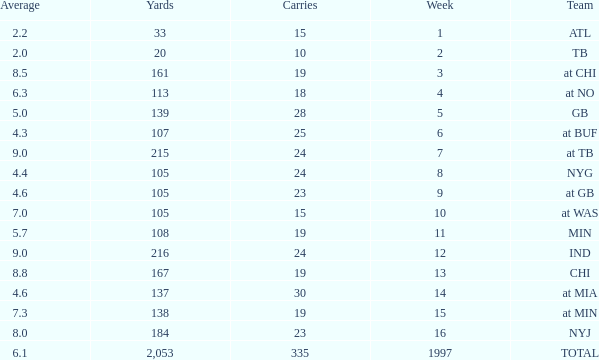Would you mind parsing the complete table? {'header': ['Average', 'Yards', 'Carries', 'Week', 'Team'], 'rows': [['2.2', '33', '15', '1', 'ATL'], ['2.0', '20', '10', '2', 'TB'], ['8.5', '161', '19', '3', 'at CHI'], ['6.3', '113', '18', '4', 'at NO'], ['5.0', '139', '28', '5', 'GB'], ['4.3', '107', '25', '6', 'at BUF'], ['9.0', '215', '24', '7', 'at TB'], ['4.4', '105', '24', '8', 'NYG'], ['4.6', '105', '23', '9', 'at GB'], ['7.0', '105', '15', '10', 'at WAS'], ['5.7', '108', '19', '11', 'MIN'], ['9.0', '216', '24', '12', 'IND'], ['8.8', '167', '19', '13', 'CHI'], ['4.6', '137', '30', '14', 'at MIA'], ['7.3', '138', '19', '15', 'at MIN'], ['8.0', '184', '23', '16', 'NYJ'], ['6.1', '2,053', '335', '1997', 'TOTAL']]} Which squad has 19 carries and a week greater than 13? At min. 